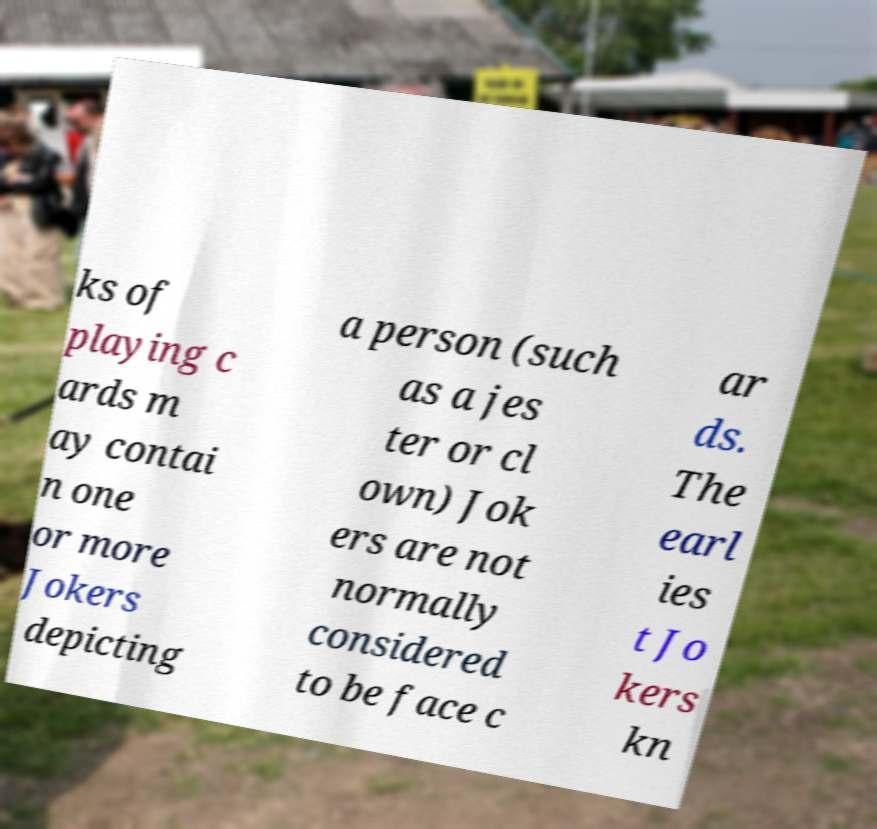What messages or text are displayed in this image? I need them in a readable, typed format. ks of playing c ards m ay contai n one or more Jokers depicting a person (such as a jes ter or cl own) Jok ers are not normally considered to be face c ar ds. The earl ies t Jo kers kn 